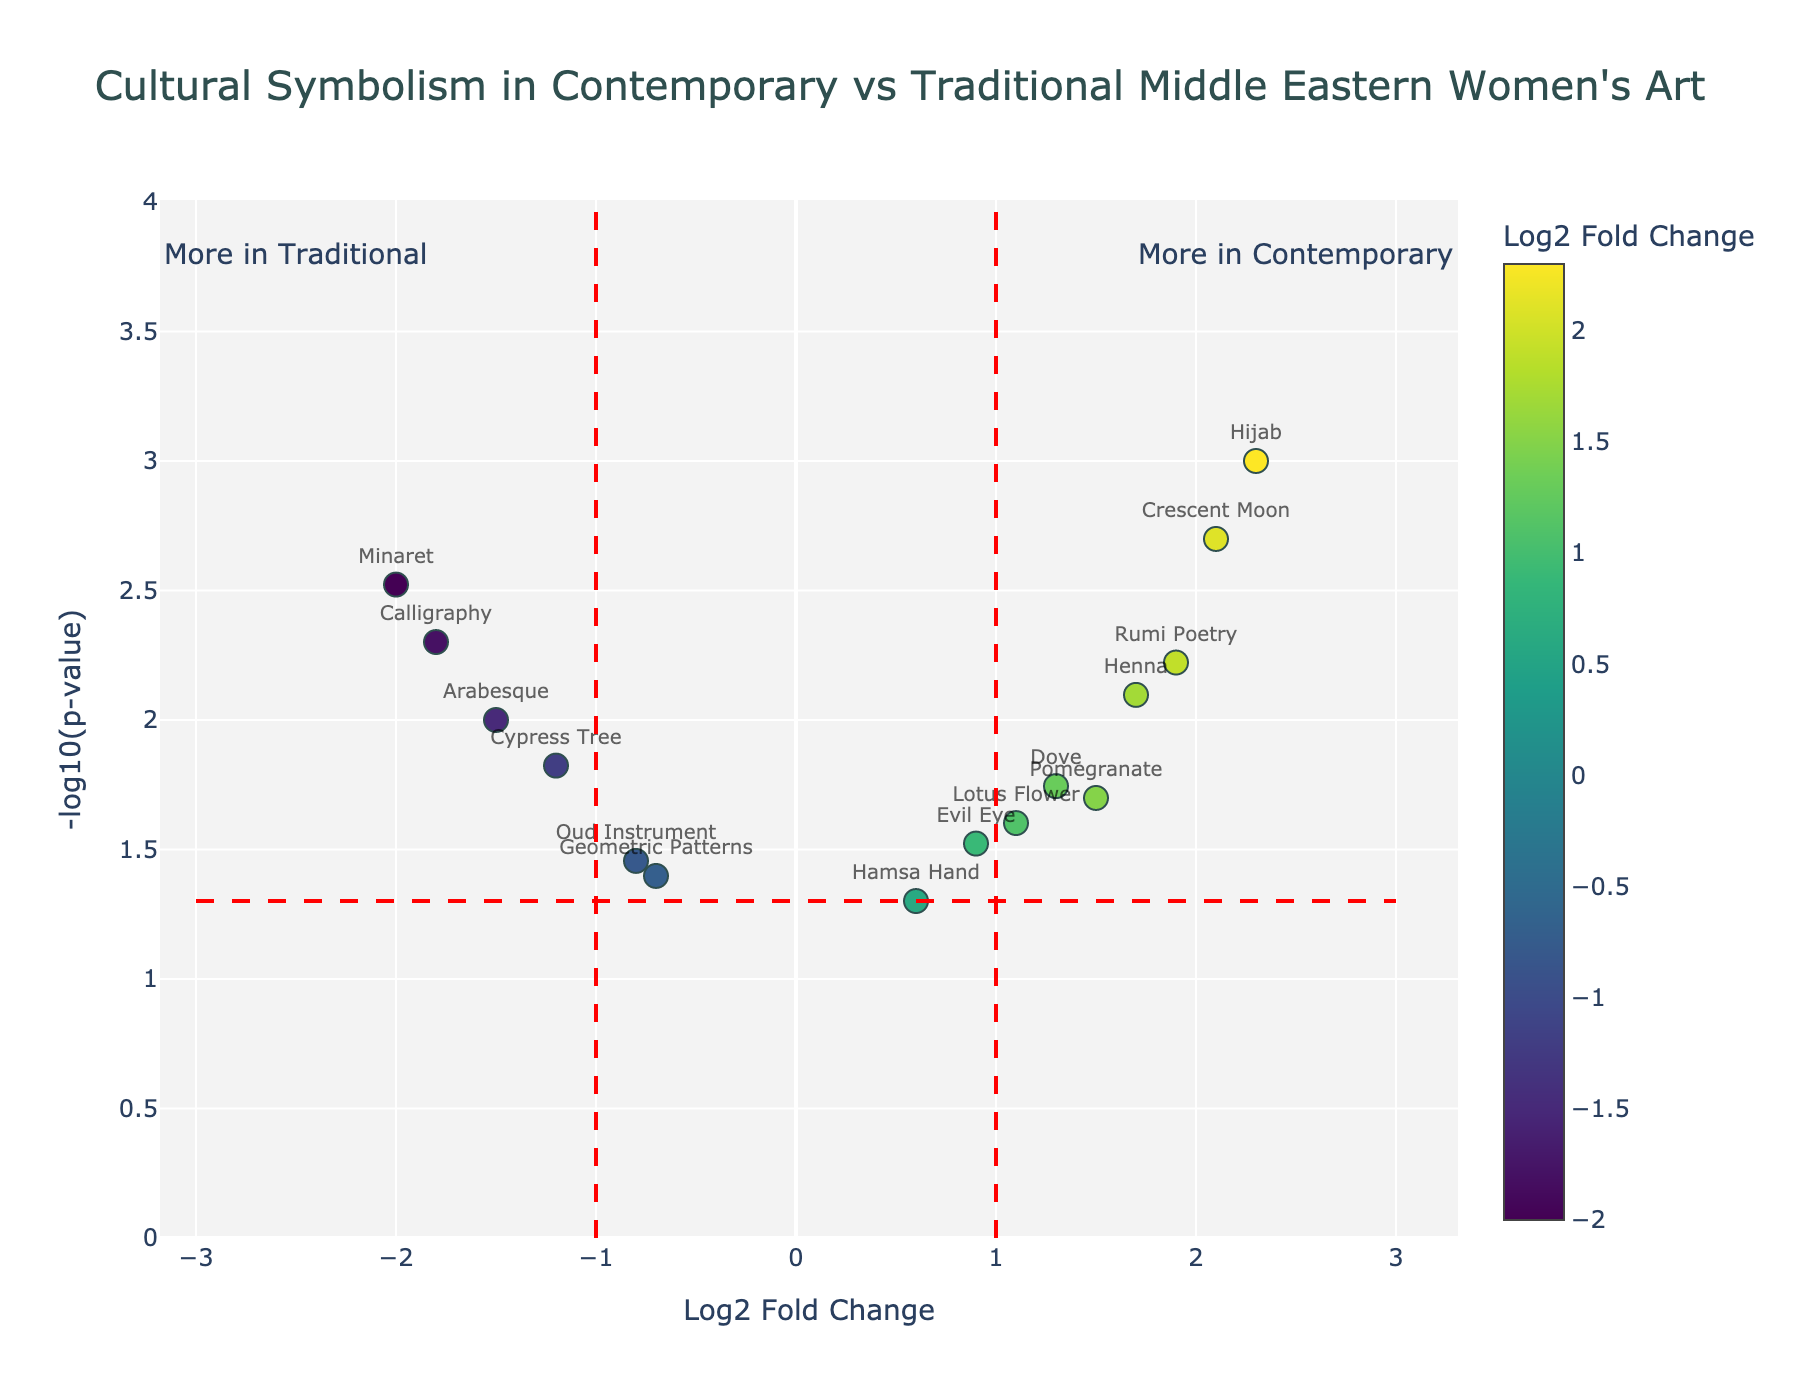What is the title of the figure? The title is located at the top of the figure and clearly states the subject of the plot.
Answer: Cultural Symbolism in Contemporary vs Traditional Middle Eastern Women's Art Which symbol shows the highest Log2 Fold Change? By looking at the x-axis and identifying the symbol farthest to the right, we can find the symbol with the highest Log2 Fold Change.
Answer: Hijab Which symbol has the lowest p-value? The y-axis represents -log10(p-value). The symbol with the highest point on the y-axis corresponds to the lowest p-value since -log10(p-value) is highest for small p-values.
Answer: Hijab How many symbols have a Log2 Fold Change greater than 1? By counting the data points to the right of the vertical red line at Log2 Fold Change = 1, we can determine the number of symbols meeting this criterion.
Answer: 6 Which symbols are more frequent in traditional art? Symbols on the left side (negative Log2 Fold Change) indicate higher frequency in traditional art. By identifying these symbols, we determine which ones are more frequent in traditional art.
Answer: Calligraphy, Cypress Tree, Geometric Patterns, Arabesque, Minaret, Oud Instrument What's the p-value for the "Henna" symbol? By locating the “Henna” symbol on the plot and noting its position on the y-axis, we can determine its p-value by converting the -log10(p-value) value back to the actual p-value. Looking at the hover text might help as well.
Answer: 0.008 Compare the significance of "Evil Eye" and "Crescent Moon". Which one is more significant? Significance is determined by the p-value (-log10(p) on y-axis). We compare their y-axis positions; the higher the position, the more significant (lower p-value).
Answer: Crescent Moon Which symbols are more frequent in contemporary art based on Log2 Fold Change? Symbols to the right side (positive Log2 Fold Change) are more frequent in contemporary art. Identifying these symbols provides the answer.
Answer: Hijab, Pomegranate, Crescent Moon, Henna, Lotus Flower, Dove, Rumi Poetry How does "Arabesque" compare to "Cypress Tree" in terms of Log2 Fold Change and p-value? To compare, we look at their x and y positions: "Arabesque" should be further left (lower Log2 Fold Change) and their y-axis positions indicate their p-values.
Answer: Both have negative Log2 Fold Change with "Arabesque" slightly more negative; "Cypress Tree" has a lower p-value What is the approximate p-value for symbols with a -log10(p-value) of 2.5? A -log10(p-value) of 2.5 converts back to a p-value using the formula p = 10^(-2.5).
Answer: 0.0032 